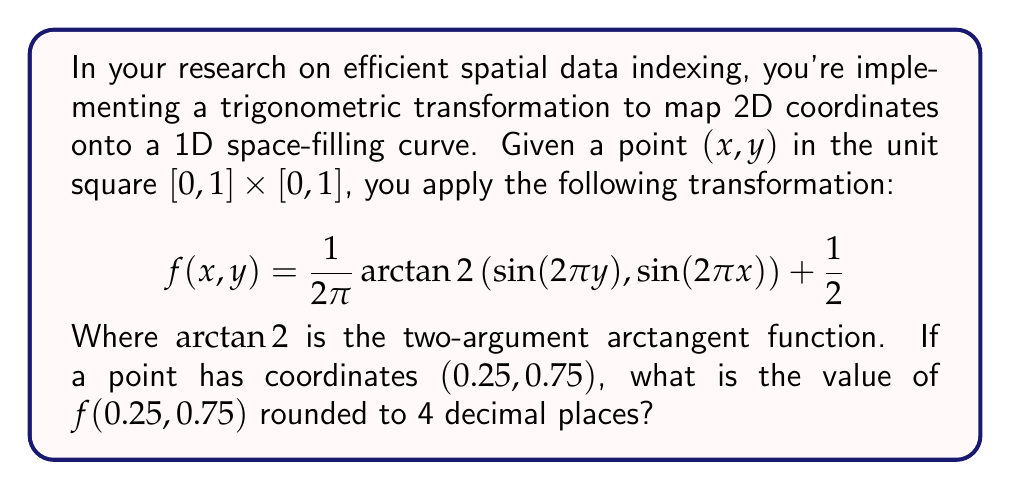Provide a solution to this math problem. Let's approach this step-by-step:

1) We're given $x = 0.25$ and $y = 0.75$. Let's substitute these into the function:

   $$f(0.25, 0.75) = \frac{1}{2\pi} \arctan2\left(\sin(2\pi \cdot 0.75), \sin(2\pi \cdot 0.25)\right) + \frac{1}{2}$$

2) First, let's calculate the arguments of $\sin$ functions:
   
   $2\pi \cdot 0.75 = 1.5\pi$
   $2\pi \cdot 0.25 = 0.5\pi$

3) Now, let's calculate the $\sin$ values:
   
   $\sin(1.5\pi) = -1$
   $\sin(0.5\pi) = 1$

4) Our function now looks like this:

   $$f(0.25, 0.75) = \frac{1}{2\pi} \arctan2(-1, 1) + \frac{1}{2}$$

5) The $\arctan2$ function with arguments $(-1, 1)$ gives us $-\frac{\pi}{4}$ or $-0.7853981634$ radians.

6) Let's substitute this back into our function:

   $$f(0.25, 0.75) = \frac{1}{2\pi} (-0.7853981634) + \frac{1}{2}$$

7) Simplify:
   
   $$f(0.25, 0.75) = -0.125 + 0.5 = 0.375$$

8) Rounding to 4 decimal places gives us 0.3750.
Answer: 0.3750 